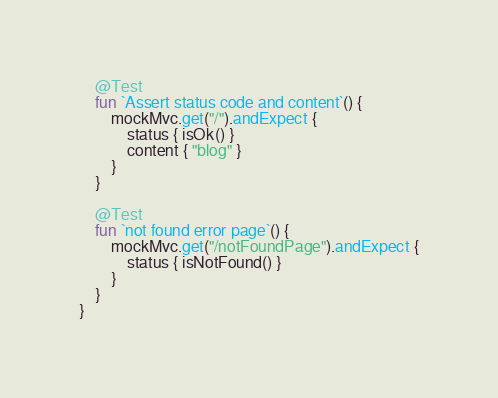<code> <loc_0><loc_0><loc_500><loc_500><_Kotlin_>	@Test
	fun `Assert status code and content`() {
		mockMvc.get("/").andExpect {
			status { isOk() }
			content { "blog" }
		}
	}

	@Test
	fun `not found error page`() {
		mockMvc.get("/notFoundPage").andExpect {
			status { isNotFound() }
		}
	}
}</code> 